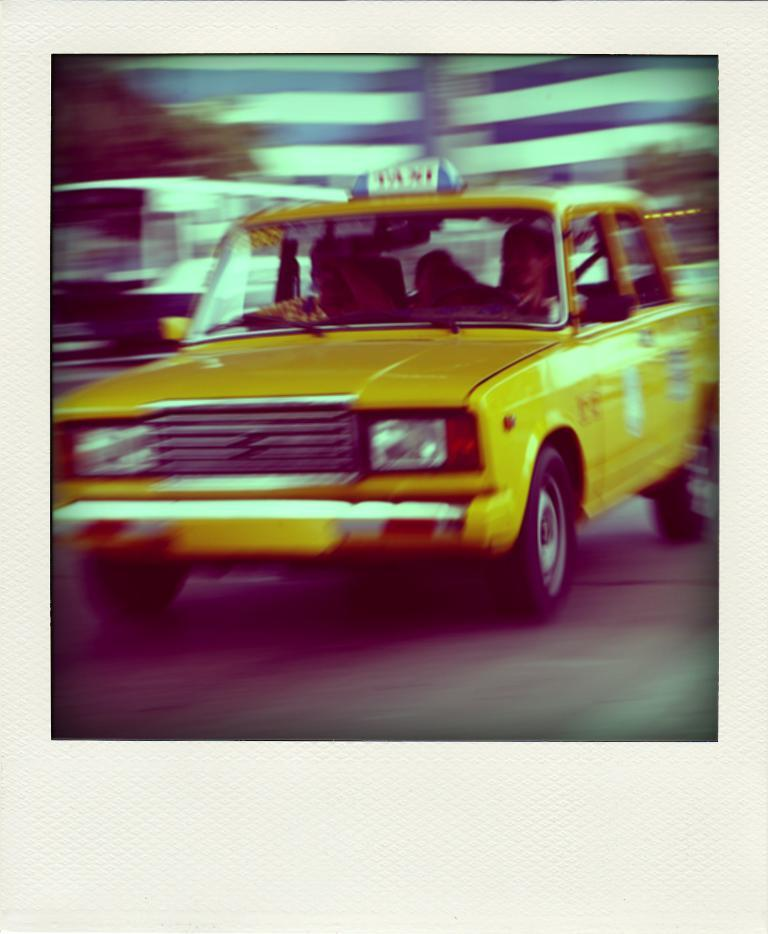Provide a one-sentence caption for the provided image. A yellow vehicle with the word Taxi on the top. 